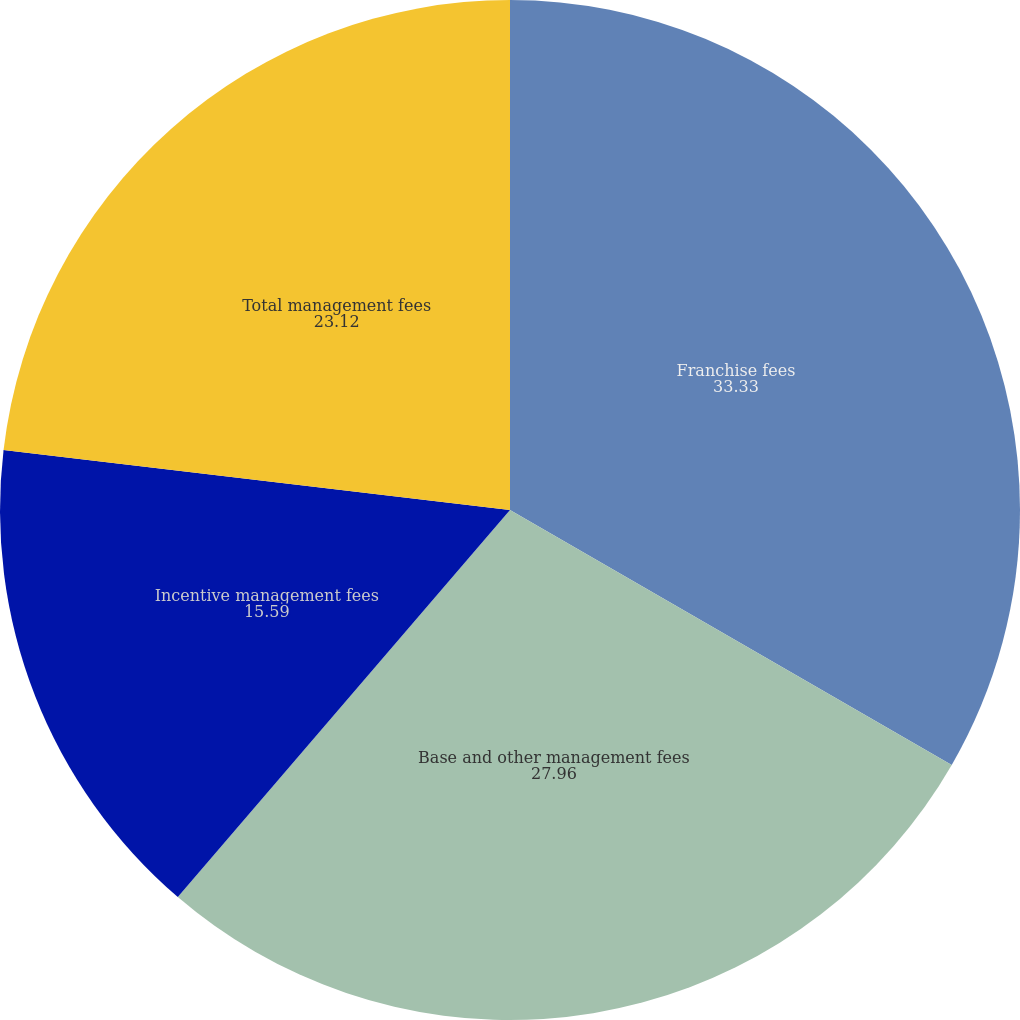Convert chart to OTSL. <chart><loc_0><loc_0><loc_500><loc_500><pie_chart><fcel>Franchise fees<fcel>Base and other management fees<fcel>Incentive management fees<fcel>Total management fees<nl><fcel>33.33%<fcel>27.96%<fcel>15.59%<fcel>23.12%<nl></chart> 